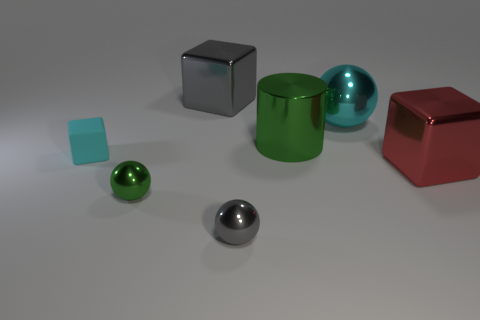Add 3 small cyan rubber blocks. How many objects exist? 10 Subtract all tiny green metal balls. How many balls are left? 2 Subtract all balls. How many objects are left? 4 Subtract all shiny cylinders. Subtract all large green objects. How many objects are left? 5 Add 6 cylinders. How many cylinders are left? 7 Add 1 gray metallic objects. How many gray metallic objects exist? 3 Subtract 0 gray cylinders. How many objects are left? 7 